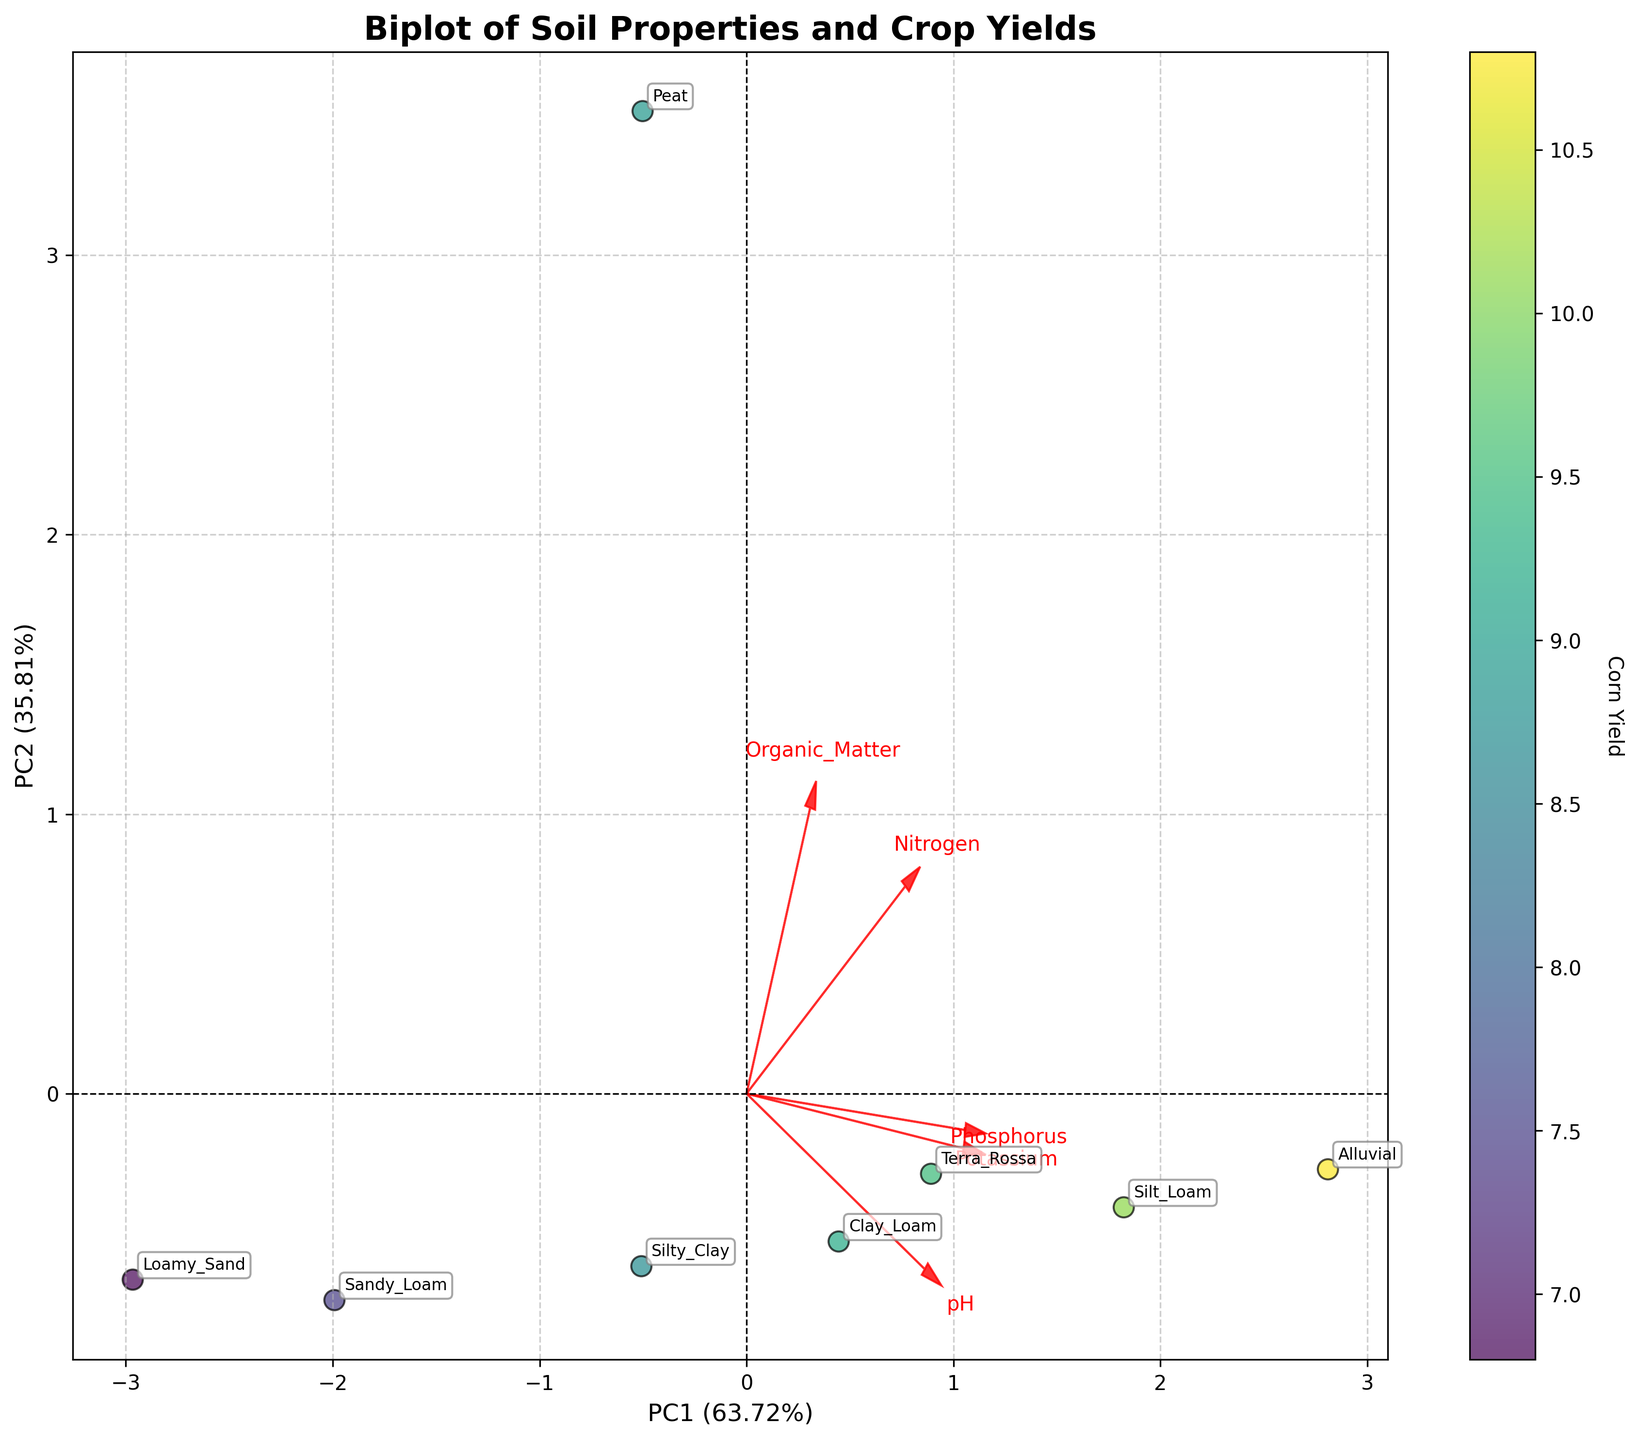What's the title of the plot? The title of the plot is written at the top of the figure. It describes the main subject of the plot.
Answer: Biplot of Soil Properties and Crop Yields What do the x-axis and y-axis represent? The labels on the x-axis and y-axis describe the principal components' variance they capture and their contribution in percentage terms.
Answer: PC1 and PC2 How are the different soil types represented in the plot? Each soil type is annotated near the corresponding data point on the biplot.
Answer: As annotated text near each data point Which soil type is furthest to the right on the first principal component (PC1)? By observing the x-axis (PC1), the soil type furthest to the right can be found.
Answer: Alluvial Which soil property has the highest loading on the first principal component (PC1)? By examining the red arrows, which represent the loadings, the soil property with the longest arrow along the x-axis can be identified.
Answer: Standardized values Which two soil properties are most correlated with each other? By observing which red arrows are the closest and pointing in the same direction, we can infer the highest correlation between properties.
Answer: Organic Matter and Nitrogen Does high Corn Yield correspond to a higher or lower value of PC1? By looking at the color gradient of the points and noting their position along the x-axis, we can infer the trend.
Answer: Higher value of PC1 Are loamy soils generally associated with higher or lower Soybean Yield based on their positions on the plot? By looking for Loam-related soils (e.g., Clay Loam, Sandy Loam) and examining their positions relative to the color gradient indicating Soybean Yield, we can determine the association.
Answer: Higher Soybean Yield Which soil property seems to negatively correlate with the second principal component (PC2)? By finding the red arrow that extends downward (negative direction of PC2), we can identify the property.
Answer: Phosphorus How can the relationship between pH and Wheat Yield be inferred from the plot? By examining the direction of the pH arrow and the color gradient corresponding to Wheat Yield, we can deduce the relationship.
Answer: Positive correlation 